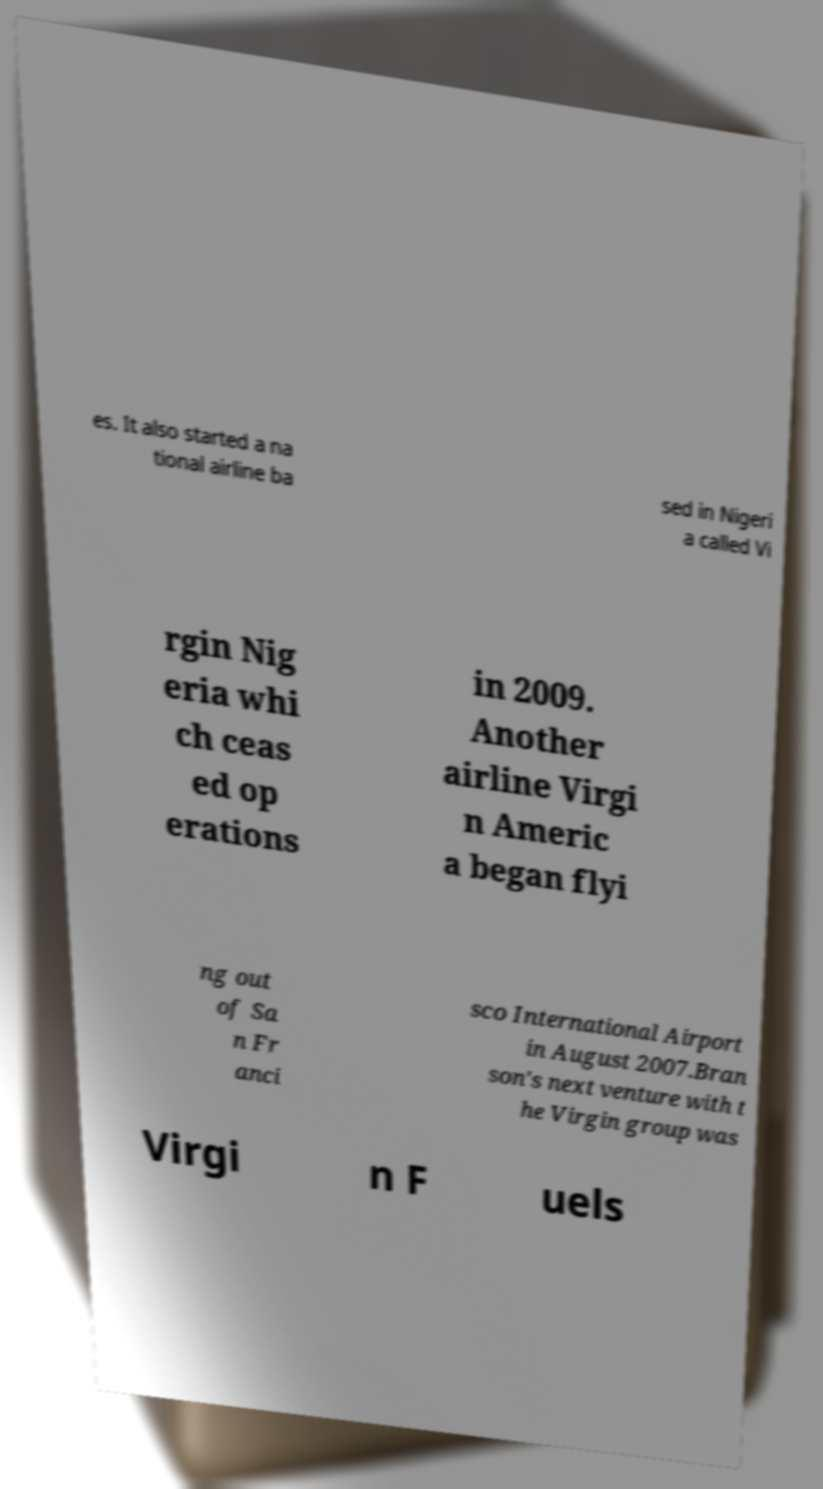I need the written content from this picture converted into text. Can you do that? es. It also started a na tional airline ba sed in Nigeri a called Vi rgin Nig eria whi ch ceas ed op erations in 2009. Another airline Virgi n Americ a began flyi ng out of Sa n Fr anci sco International Airport in August 2007.Bran son's next venture with t he Virgin group was Virgi n F uels 